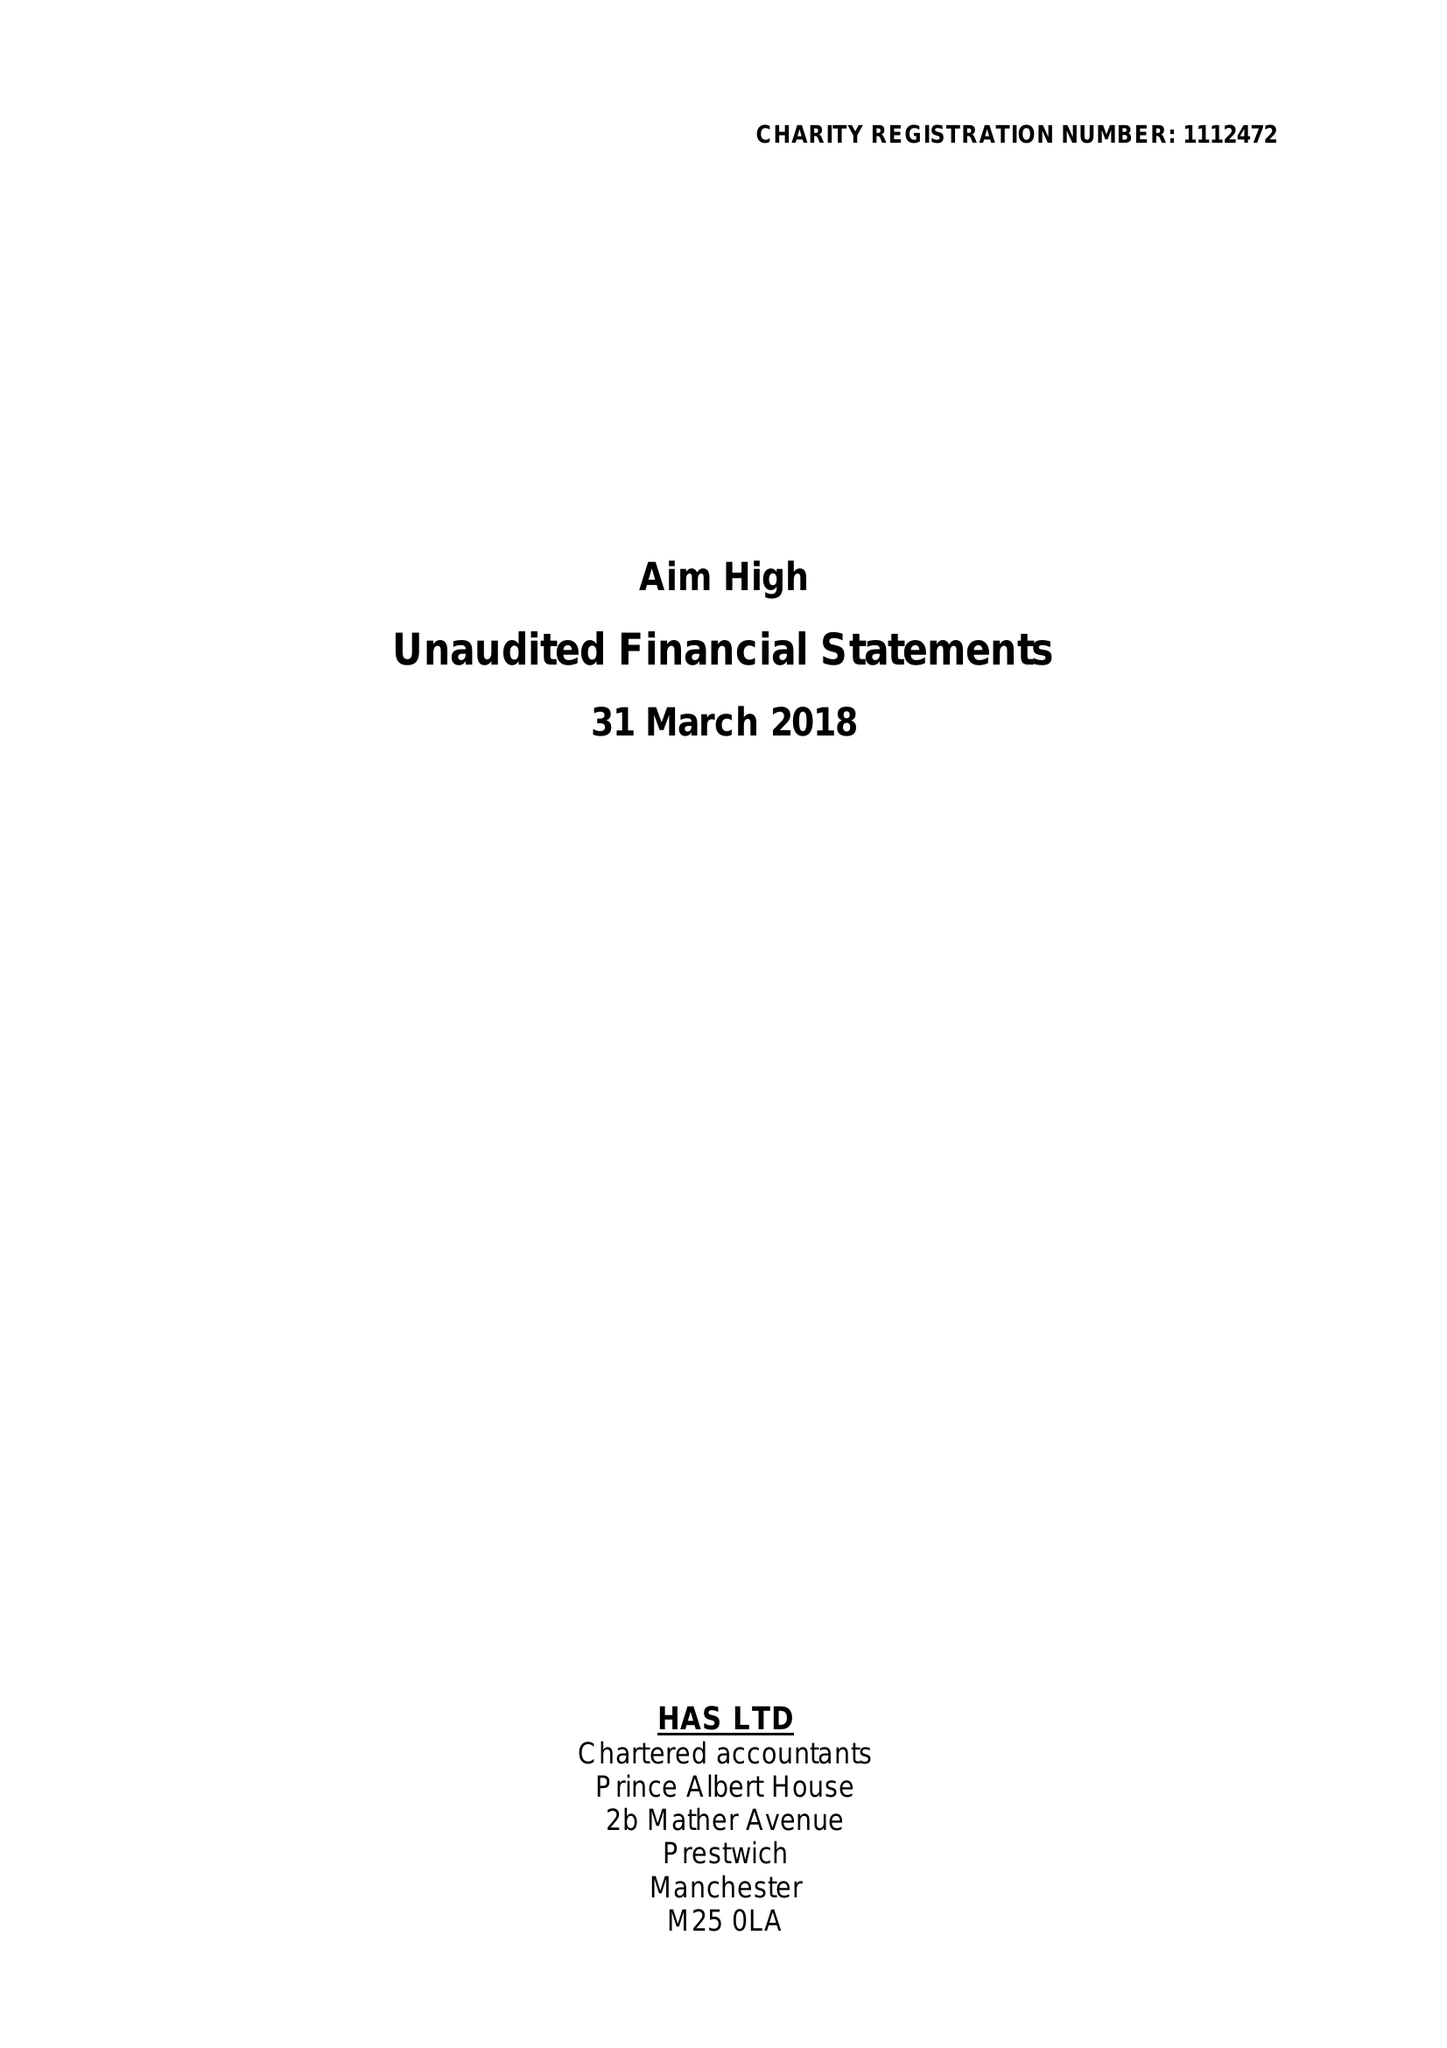What is the value for the address__postcode?
Answer the question using a single word or phrase. M25 0LN 